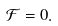<formula> <loc_0><loc_0><loc_500><loc_500>\mathcal { F } = 0 .</formula> 